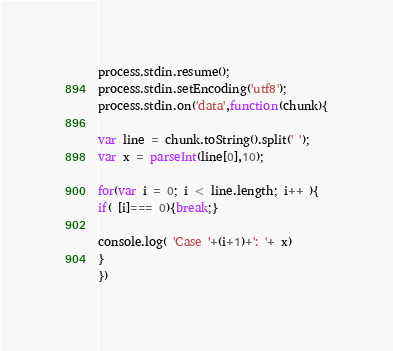<code> <loc_0><loc_0><loc_500><loc_500><_JavaScript_>process.stdin.resume();
process.stdin.setEncoding('utf8');
process.stdin.on('data',function(chunk){

var line = chunk.toString().split(' ');
var x = parseInt(line[0],10);

for(var i = 0; i < line.length; i++ ){
if( [i]=== 0){break;}

console.log( 'Case '+(i+1)+': '+ x)
}
})</code> 